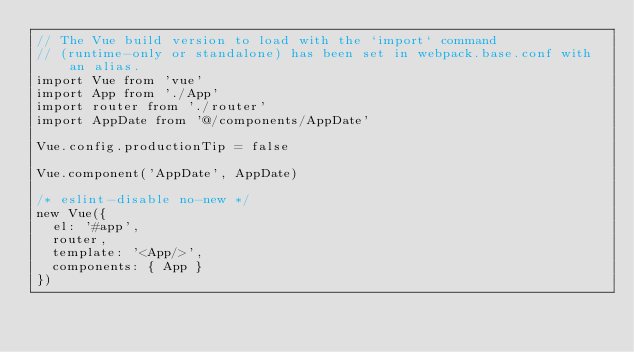Convert code to text. <code><loc_0><loc_0><loc_500><loc_500><_JavaScript_>// The Vue build version to load with the `import` command
// (runtime-only or standalone) has been set in webpack.base.conf with an alias.
import Vue from 'vue'
import App from './App'
import router from './router'
import AppDate from '@/components/AppDate'

Vue.config.productionTip = false

Vue.component('AppDate', AppDate)

/* eslint-disable no-new */
new Vue({
  el: '#app',
  router,
  template: '<App/>',
  components: { App }
})
</code> 